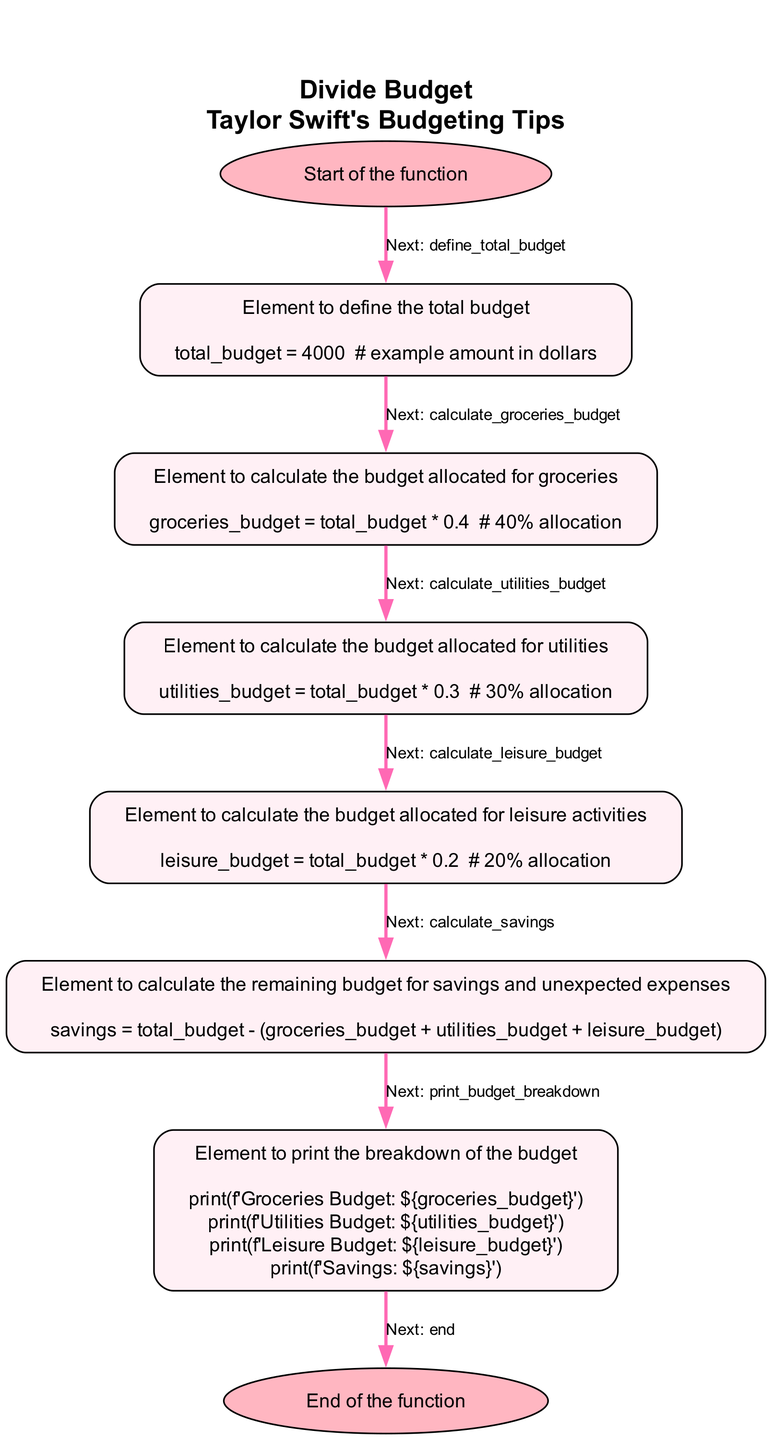What is the total budget defined at the start? The function begins by defining the total budget with a code snippet that sets it to 4000 dollars. This value is explicitly mentioned in the step labeled 'define_total_budget'.
Answer: 4000 What percentage of the budget is allocated for groceries? The step labeled 'calculate_groceries_budget' states that 40% of the total budget is allocated for groceries, as indicated by the code snippet provided.
Answer: 40% How many budget allocation categories are there in total? By reviewing the flowchart, we can identify that there are four main categories: groceries, utilities, leisure, and savings. This includes the initial step of budgeting, leading us to conclude there are five steps that relate to budget allocation.
Answer: five What is the savings calculated from the total budget? In the 'calculate_savings' step, the savings are derived by subtracting the sum of groceries, utilities, and leisure from the total budget of 4000 dollars. This calculation leads to the remainder amount being identified as savings.
Answer: 600 What is printed in the budget breakdown? The step 'print_budget_breakdown' contains multiple print statements detailing the budget for groceries, utilities, leisure, and savings. Each category is specifically labeled in the output.
Answer: Groceries Budget, Utilities Budget, Leisure Budget, Savings What is the next step after calculating the utilities budget? The flowchart indicates that after calculating the budget for utilities, the next step is to calculate the budget allocated for leisure activities, directed by the label 'next' that follows the utilities calculation.
Answer: calculate_leisure_budget Which step comes before the end of the function? In the flowchart, the final operation before reaching the end is the 'print_budget_breakdown' step, which is crucial for showing the results of the budget allocation calculations.
Answer: print_budget_breakdown What color represents the start and end of the function? The function visually differentiates the start and end steps with the oval shape filled with a light pink color (#FFB6C1), clearly indicated in the diagram.
Answer: light pink What is the percentage saved after budgeting for all categories? By allocating 40% for groceries, 30% for utilities, and 20% for leisure, the percentage for savings can be determined by subtracting the total of these allocations from 100%, resulting in a final savings percentage of 10%.
Answer: 10% 